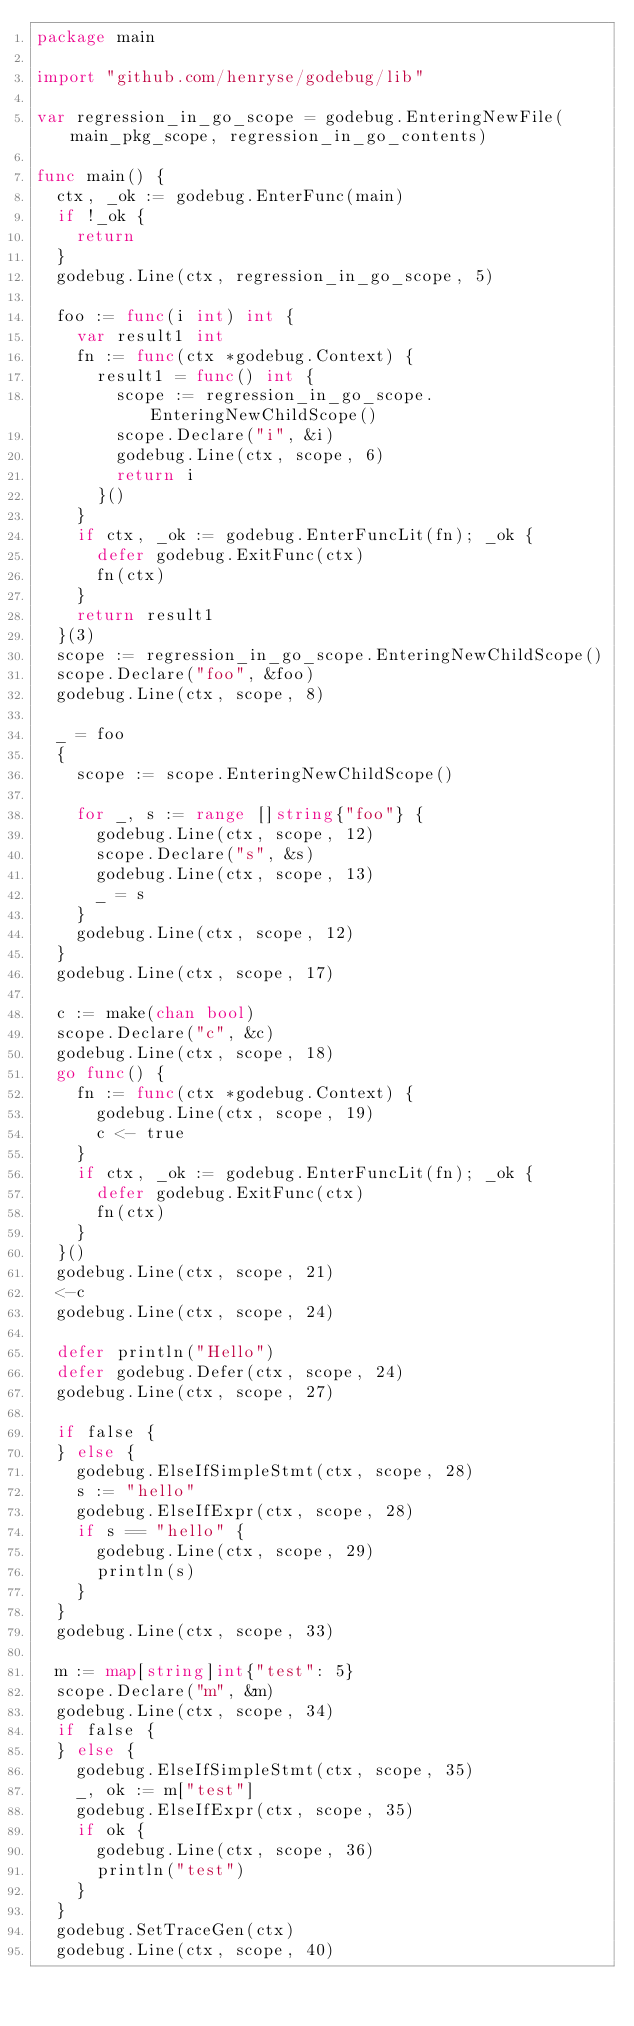Convert code to text. <code><loc_0><loc_0><loc_500><loc_500><_Go_>package main

import "github.com/henryse/godebug/lib"

var regression_in_go_scope = godebug.EnteringNewFile(main_pkg_scope, regression_in_go_contents)

func main() {
	ctx, _ok := godebug.EnterFunc(main)
	if !_ok {
		return
	}
	godebug.Line(ctx, regression_in_go_scope, 5)

	foo := func(i int) int {
		var result1 int
		fn := func(ctx *godebug.Context) {
			result1 = func() int {
				scope := regression_in_go_scope.EnteringNewChildScope()
				scope.Declare("i", &i)
				godebug.Line(ctx, scope, 6)
				return i
			}()
		}
		if ctx, _ok := godebug.EnterFuncLit(fn); _ok {
			defer godebug.ExitFunc(ctx)
			fn(ctx)
		}
		return result1
	}(3)
	scope := regression_in_go_scope.EnteringNewChildScope()
	scope.Declare("foo", &foo)
	godebug.Line(ctx, scope, 8)

	_ = foo
	{
		scope := scope.EnteringNewChildScope()

		for _, s := range []string{"foo"} {
			godebug.Line(ctx, scope, 12)
			scope.Declare("s", &s)
			godebug.Line(ctx, scope, 13)
			_ = s
		}
		godebug.Line(ctx, scope, 12)
	}
	godebug.Line(ctx, scope, 17)

	c := make(chan bool)
	scope.Declare("c", &c)
	godebug.Line(ctx, scope, 18)
	go func() {
		fn := func(ctx *godebug.Context) {
			godebug.Line(ctx, scope, 19)
			c <- true
		}
		if ctx, _ok := godebug.EnterFuncLit(fn); _ok {
			defer godebug.ExitFunc(ctx)
			fn(ctx)
		}
	}()
	godebug.Line(ctx, scope, 21)
	<-c
	godebug.Line(ctx, scope, 24)

	defer println("Hello")
	defer godebug.Defer(ctx, scope, 24)
	godebug.Line(ctx, scope, 27)

	if false {
	} else {
		godebug.ElseIfSimpleStmt(ctx, scope, 28)
		s := "hello"
		godebug.ElseIfExpr(ctx, scope, 28)
		if s == "hello" {
			godebug.Line(ctx, scope, 29)
			println(s)
		}
	}
	godebug.Line(ctx, scope, 33)

	m := map[string]int{"test": 5}
	scope.Declare("m", &m)
	godebug.Line(ctx, scope, 34)
	if false {
	} else {
		godebug.ElseIfSimpleStmt(ctx, scope, 35)
		_, ok := m["test"]
		godebug.ElseIfExpr(ctx, scope, 35)
		if ok {
			godebug.Line(ctx, scope, 36)
			println("test")
		}
	}
	godebug.SetTraceGen(ctx)
	godebug.Line(ctx, scope, 40)</code> 